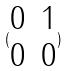Convert formula to latex. <formula><loc_0><loc_0><loc_500><loc_500>( \begin{matrix} 0 & 1 \\ 0 & 0 \end{matrix} )</formula> 